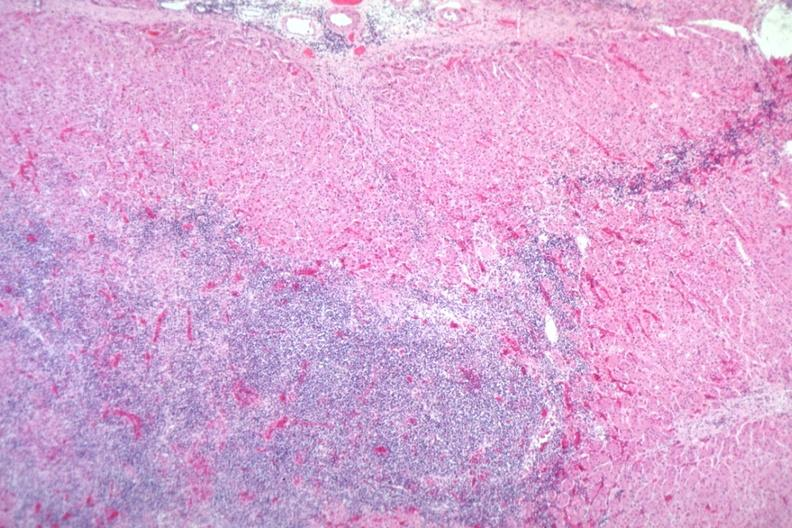s angiogram present?
Answer the question using a single word or phrase. No 